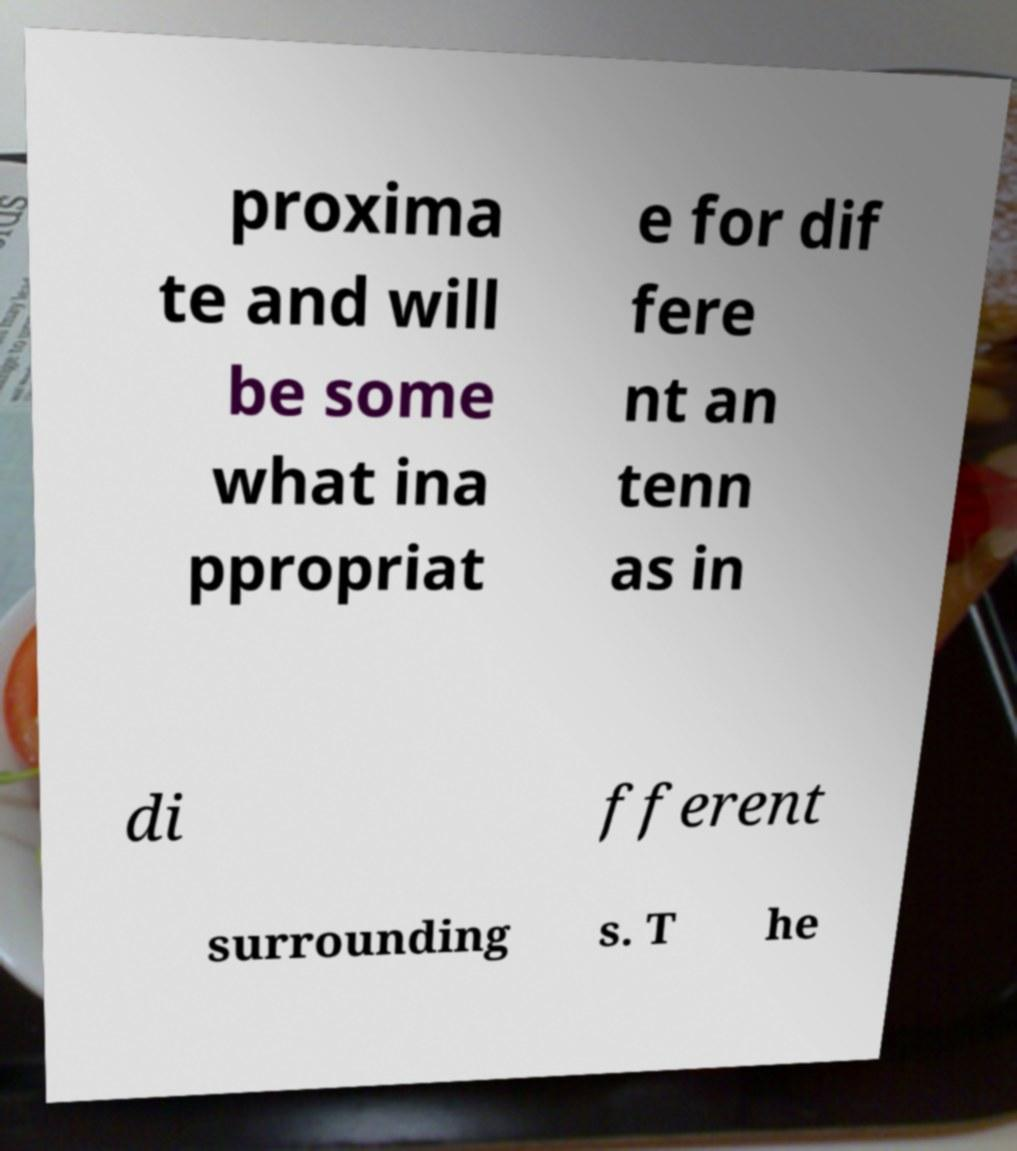Please read and relay the text visible in this image. What does it say? proxima te and will be some what ina ppropriat e for dif fere nt an tenn as in di fferent surrounding s. T he 